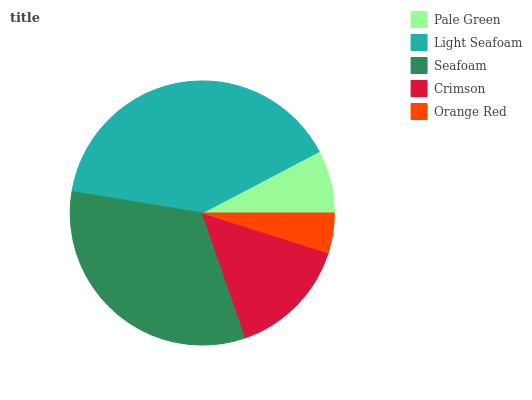Is Orange Red the minimum?
Answer yes or no. Yes. Is Light Seafoam the maximum?
Answer yes or no. Yes. Is Seafoam the minimum?
Answer yes or no. No. Is Seafoam the maximum?
Answer yes or no. No. Is Light Seafoam greater than Seafoam?
Answer yes or no. Yes. Is Seafoam less than Light Seafoam?
Answer yes or no. Yes. Is Seafoam greater than Light Seafoam?
Answer yes or no. No. Is Light Seafoam less than Seafoam?
Answer yes or no. No. Is Crimson the high median?
Answer yes or no. Yes. Is Crimson the low median?
Answer yes or no. Yes. Is Seafoam the high median?
Answer yes or no. No. Is Pale Green the low median?
Answer yes or no. No. 